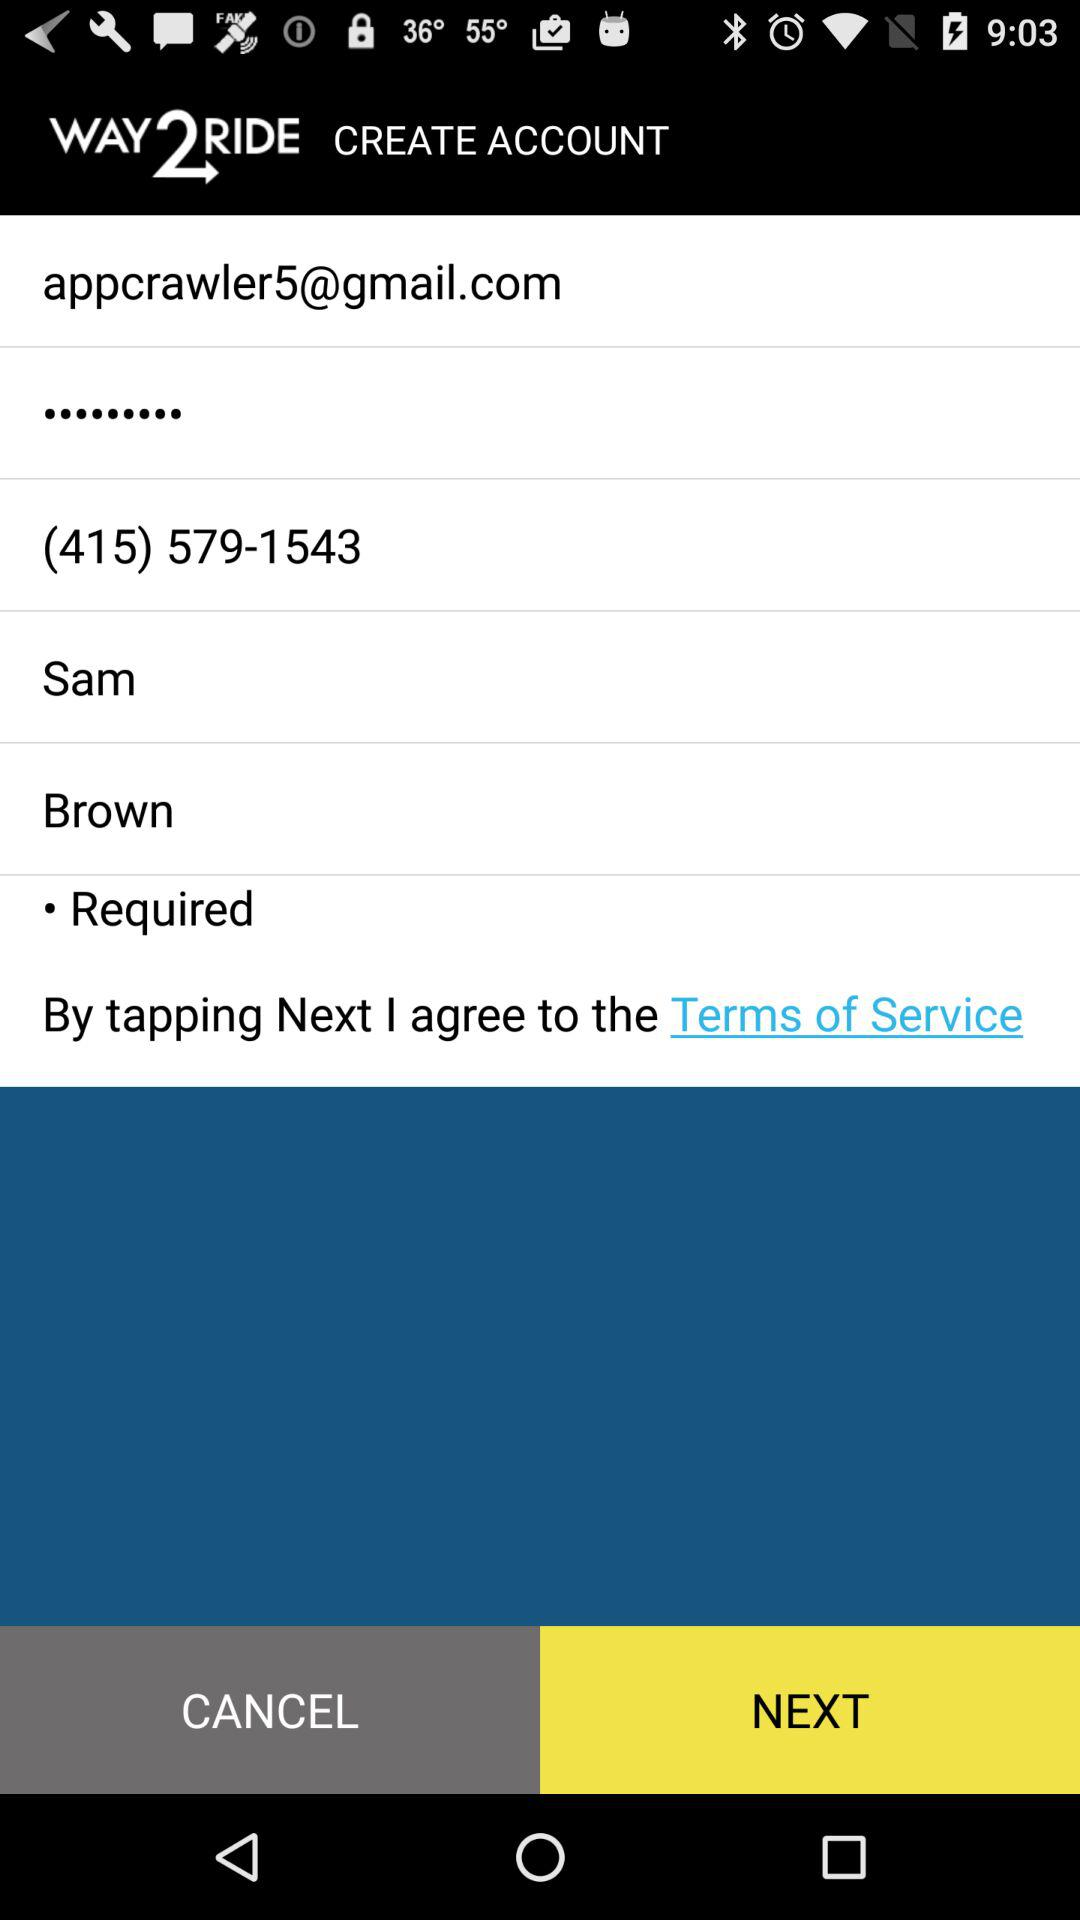What is the email address? The email address is appcrawler5@gmail.com. 